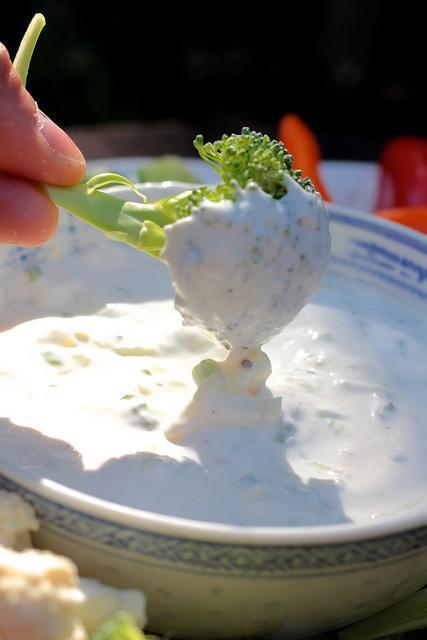Is the statement "The broccoli is at the left side of the person." accurate regarding the image?
Answer yes or no. No. 